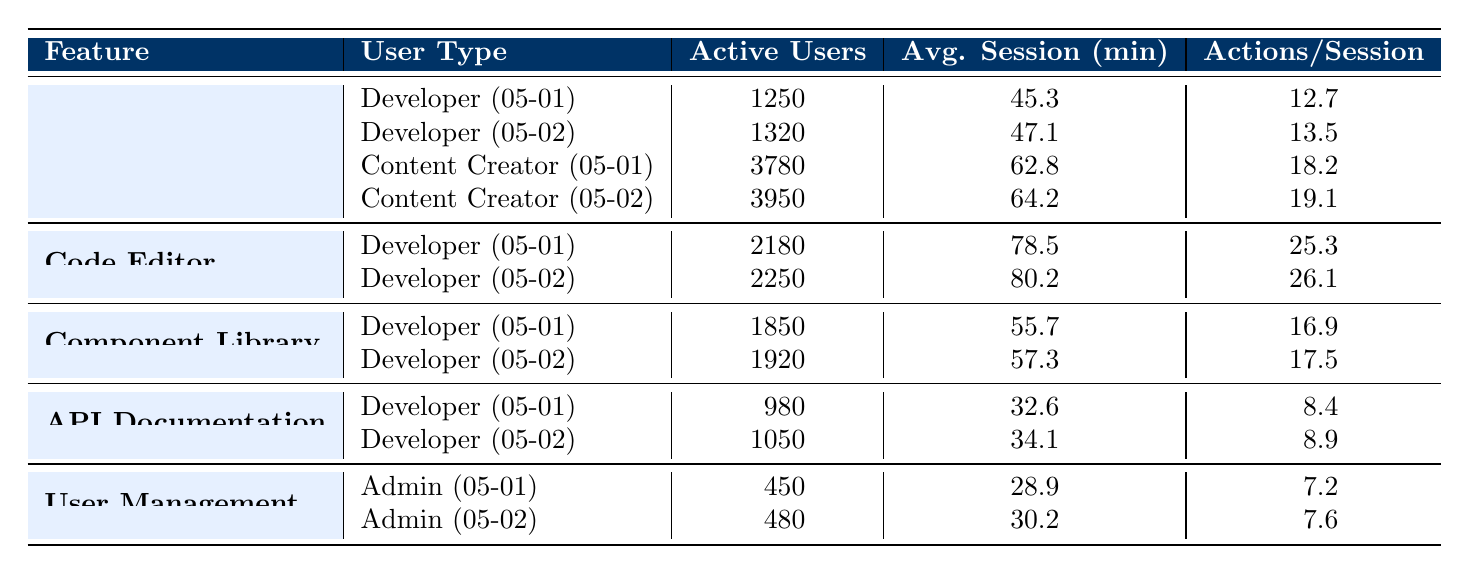What feature had the highest number of active users on May 2nd? Looking at the "active users" column for May 2nd, the "React Froala Editor" had 3950 active users, which is higher than the other features on that date.
Answer: React Froala Editor What was the average session duration for Content Creators using the React Froala Editor over the two days? To calculate the average session duration for Content Creators using the React Froala Editor, we take the values 62.8 (from May 1st) and 64.2 (from May 2nd), sum them to get 127.0, and divide by 2 which gives us 127.0 / 2 = 63.5 minutes.
Answer: 63.5 minutes Did the average session duration for Developers increase or decrease from May 1st to May 2nd for the Code Editor? For Developers using the Code Editor, the average session duration was 78.5 minutes on May 1st and increased to 80.2 minutes on May 2nd, indicating an increase.
Answer: Increase How many total active users were there for the Developer user type across all features on May 2nd? From May 2nd, the active users for Developers are as follows: 1320 (React Froala Editor) + 2250 (Code Editor) + 1920 (Component Library) + 1050 (API Documentation) = 5940.
Answer: 5940 Which feature had the lowest average actions per session for Developers on May 1st? The feature with the lowest average actions per session for Developers on May 1st is the "API Documentation" with 8.4 actions per session, compared to others.
Answer: API Documentation Was there an overall increase in active users across all features from May 1st to May 2nd? Summing active users on May 1st gives us 1250 + 3780 + 2180 + 1850 + 980 + 450 = 10590, and for May 2nd it’s 1320 + 3950 + 2250 + 1920 + 1050 + 480 = 10970. Since 10970 is greater than 10590, there was an increase.
Answer: Yes What is the difference in active users for the Developer user type between May 1st and May 2nd for the Component Library? On May 1st, there were 1850 active users, and on May 2nd there were 1920 active users. The difference is 1920 - 1850 = 70.
Answer: 70 Which user type spent the most average session duration on the React Froala Editor? Comparing the average session durations for Developers (45.3 on May 1st and 47.1 on May 2nd) and Content Creators (62.8 on May 1st and 64.2 on May 2nd), Content Creators had higher durations of 62.8 and 64.2.
Answer: Content Creator 